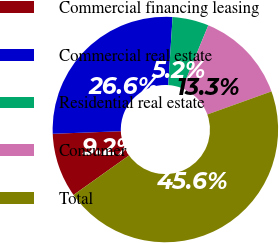<chart> <loc_0><loc_0><loc_500><loc_500><pie_chart><fcel>Commercial financing leasing<fcel>Commercial real estate<fcel>Residential real estate<fcel>Consumer<fcel>Total<nl><fcel>9.25%<fcel>26.62%<fcel>5.2%<fcel>13.29%<fcel>45.64%<nl></chart> 